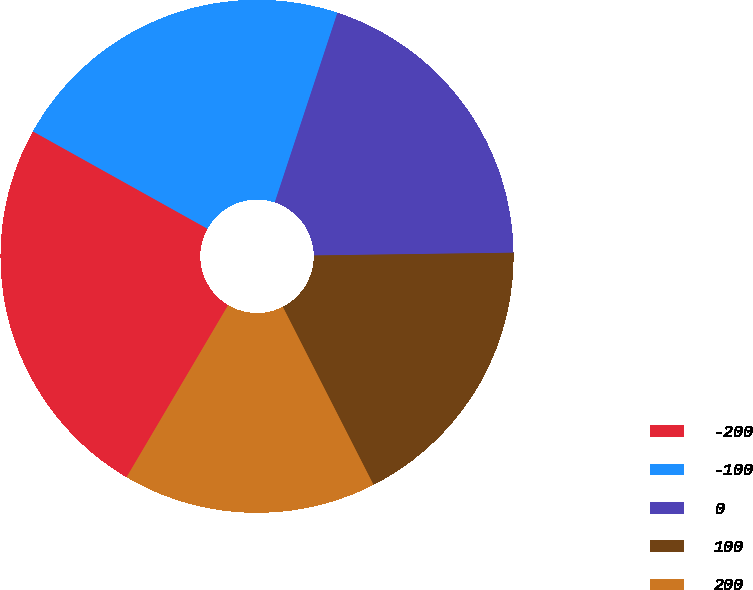Convert chart to OTSL. <chart><loc_0><loc_0><loc_500><loc_500><pie_chart><fcel>-200<fcel>-100<fcel>0<fcel>100<fcel>200<nl><fcel>24.61%<fcel>21.98%<fcel>19.7%<fcel>17.72%<fcel>15.99%<nl></chart> 